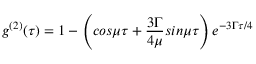<formula> <loc_0><loc_0><loc_500><loc_500>g ^ { ( 2 ) } ( \tau ) = 1 - \left ( \cos \mu \tau + { \frac { 3 \Gamma } { 4 \mu } } \sin \mu \tau \right ) e ^ { - 3 \Gamma \tau / 4 }</formula> 